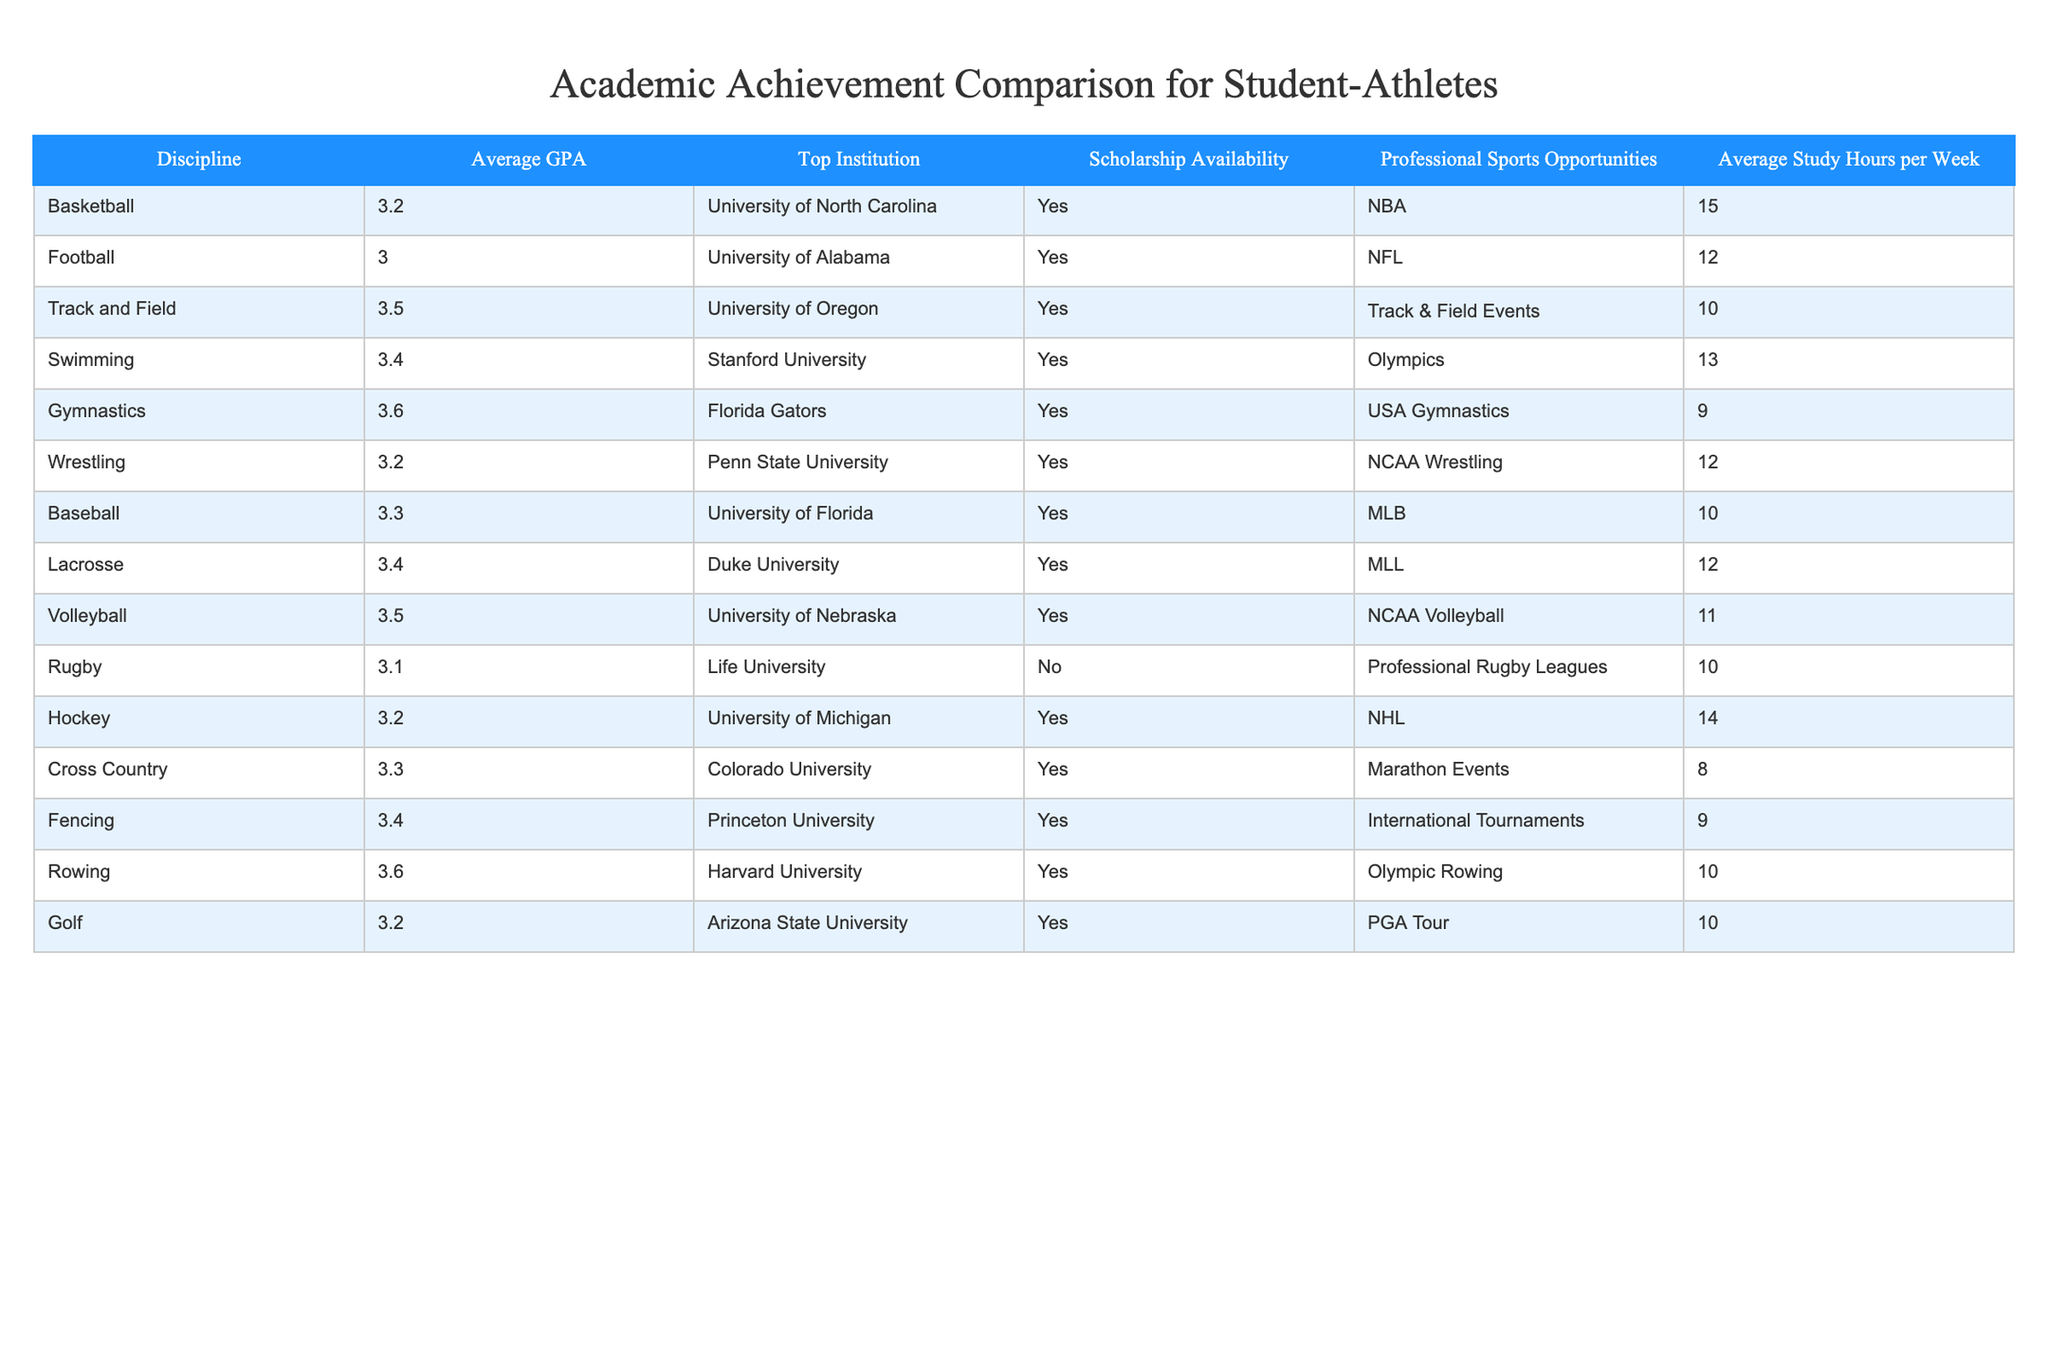What is the average GPA for student-athletes participating in Lacrosse? Looking at the table, Lacrosse has an average GPA of 3.4 listed next to it. Therefore, the average GPA for student-athletes in Lacrosse is directly available in the data.
Answer: 3.4 Which discipline has the lowest average study hours per week? In the table, we can see that Gymnastics has the lowest average study hours per week at 9 hours. By comparing the average study hours across all disciplines, Gymnastics stands out as the lowest.
Answer: 9 Is there a professional sports opportunity available for all the disciplines listed? By analyzing the 'Scholarship Availability' column, Rugby is the only discipline with "No," indicating that not all disciplines have professional sports opportunities. This means that only one sport, Rugby, does not offer this opportunity.
Answer: No How many more hours do student-athletes in Basketball spend studying compared to those in Rugby? Basketball has an average of 15 study hours, while Rugby has only 10 hours. The difference is calculated by subtracting Rugby's hours from Basketball's: 15 - 10 = 5. Therefore, student-athletes in Basketball study 5 hours more per week than those in Rugby.
Answer: 5 Which discipline has the highest average GPA, and what is the value? Referring to the table, Gymnastics and Rowing both have the highest average GPA of 3.6. By scanning the average GPA column, we can confirm that both disciplines achieve this score, and it’s the highest among all.
Answer: 3.6 If a student-athlete with a GPA of 3.1 wants to switch to a discipline with a higher average GPA, which disciplines are options? Observing the GPA values, the disciplines with a higher average GPA than 3.1 include Track and Field (3.5), Swimming (3.4), Volleyball (3.5), Lacrosse (3.4), Baseball (3.3), Hockey (3.2), and Fencing (3.4). Therefore, there are several options available for the student-athlete who wishes to switch.
Answer: Track and Field, Swimming, Volleyball, Lacrosse, Baseball, Hockey, Fencing What institutions offer scholarships for the highest GPA disciplines? Analyzing the table, Gymnastics and Rowing have the highest GPA at 3.6, both of which also have "Yes" under the Scholarship Availability column, indicating scholarships are available at their respective institutions, Florida Gators for Gymnastics and Harvard University for Rowing.
Answer: Florida Gators, Harvard University What is the ratio of average study hours of Football to that of Swimming? Football has an average of 12 study hours while Swimming has 13. The ratio can be calculated by comparing these two values: 12:13. This shows that for every hour Football students study, Swimming students study slightly more in relation. The ratio can also be expressed as a fraction (12/13).
Answer: 12:13 